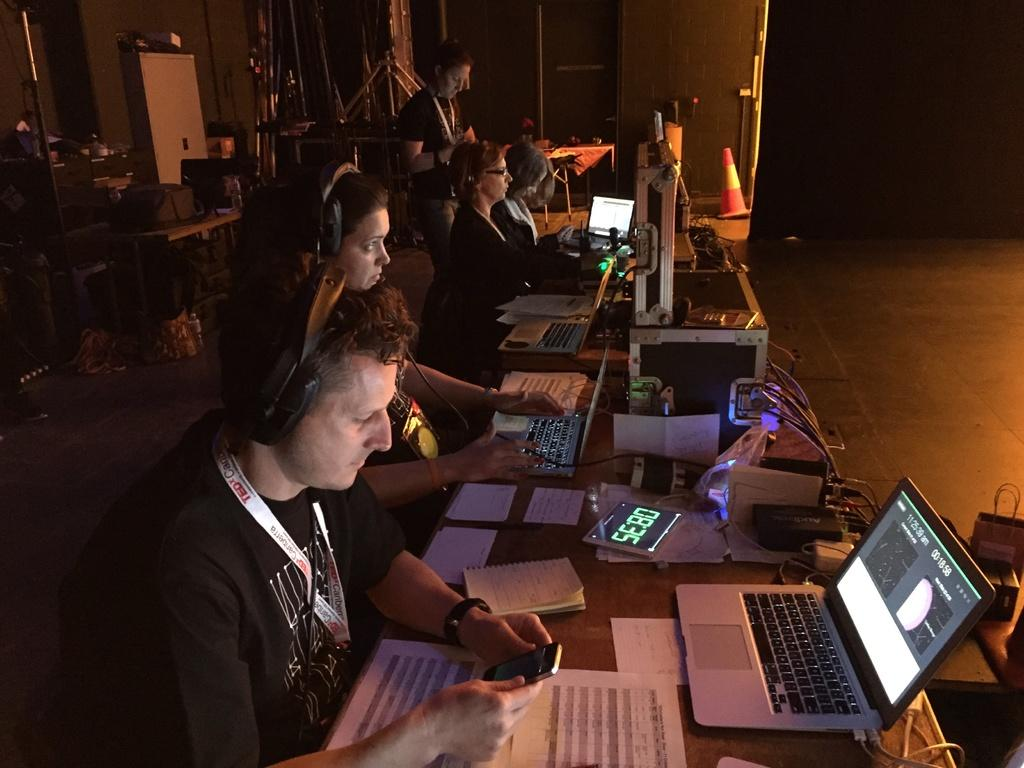What are the people in the image doing? The people in the image are operating laptops. What else can be seen in the image besides the people and laptops? There are papers and a digital clock in the image. What object might be used for directing traffic in the image? There is a traffic cone in the image. What type of hammer can be seen in the image? There is no hammer present in the image. How many family members are visible in the image? There is no reference to a family or family members in the image. 